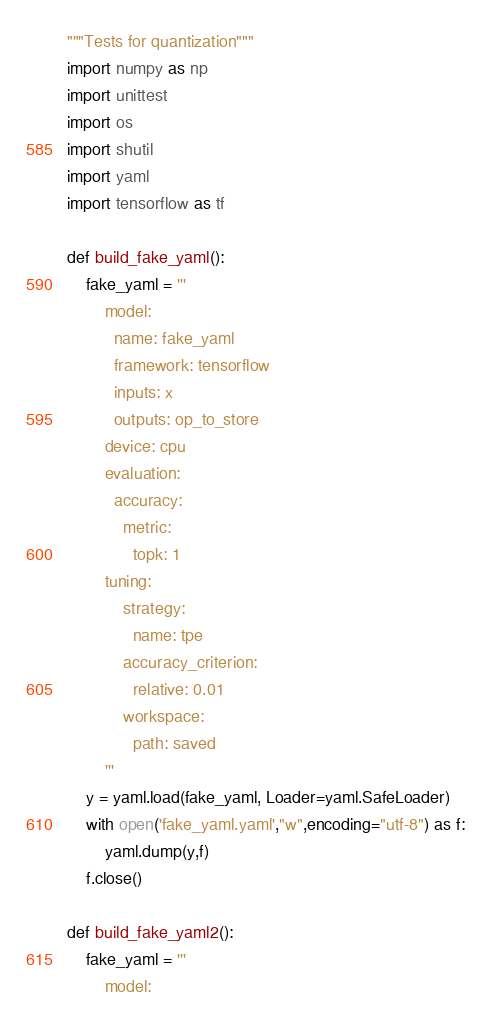Convert code to text. <code><loc_0><loc_0><loc_500><loc_500><_Python_>"""Tests for quantization"""
import numpy as np
import unittest
import os
import shutil
import yaml
import tensorflow as tf

def build_fake_yaml():
    fake_yaml = '''
        model:
          name: fake_yaml
          framework: tensorflow
          inputs: x
          outputs: op_to_store
        device: cpu
        evaluation:
          accuracy:
            metric:
              topk: 1
        tuning:
            strategy:
              name: tpe
            accuracy_criterion:
              relative: 0.01
            workspace:
              path: saved
        '''
    y = yaml.load(fake_yaml, Loader=yaml.SafeLoader)
    with open('fake_yaml.yaml',"w",encoding="utf-8") as f:
        yaml.dump(y,f)
    f.close()

def build_fake_yaml2():
    fake_yaml = '''
        model:</code> 